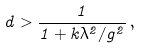Convert formula to latex. <formula><loc_0><loc_0><loc_500><loc_500>d > \frac { 1 } { 1 + k \lambda ^ { 2 } / g ^ { 2 } } \, ,</formula> 